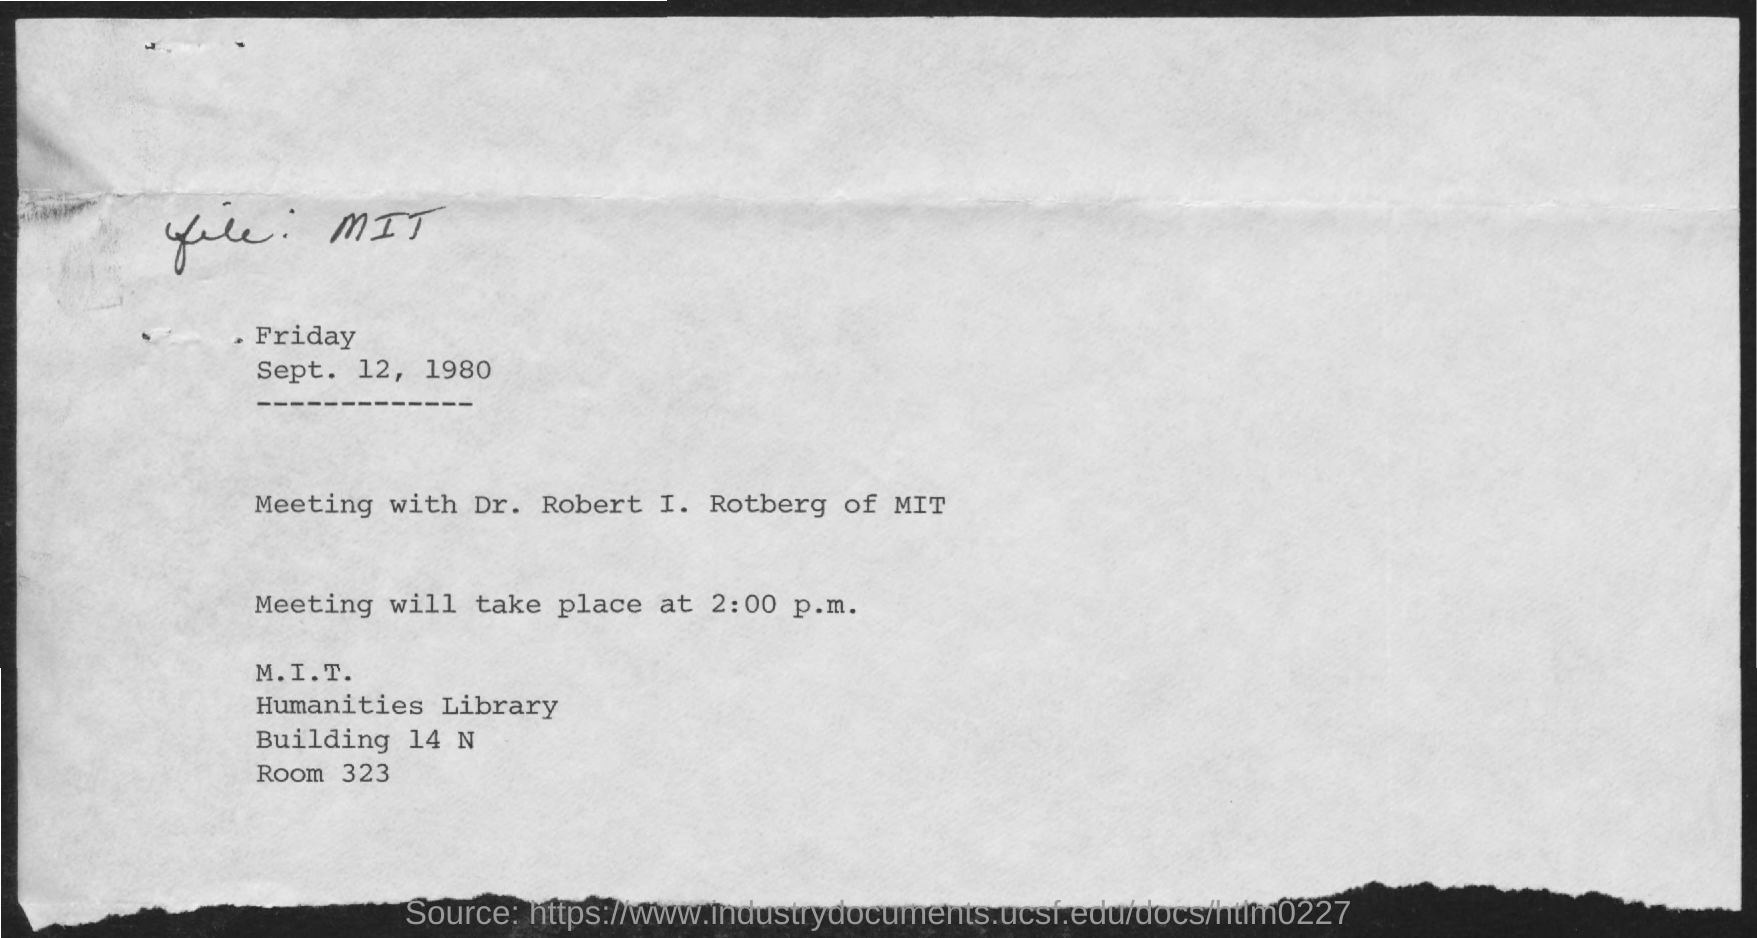Give some essential details in this illustration. The date on the document is September 12, 1980. The meeting is scheduled to take place at 2:00 p.m. The meeting is with Dr. Robert I. Rotberg. 